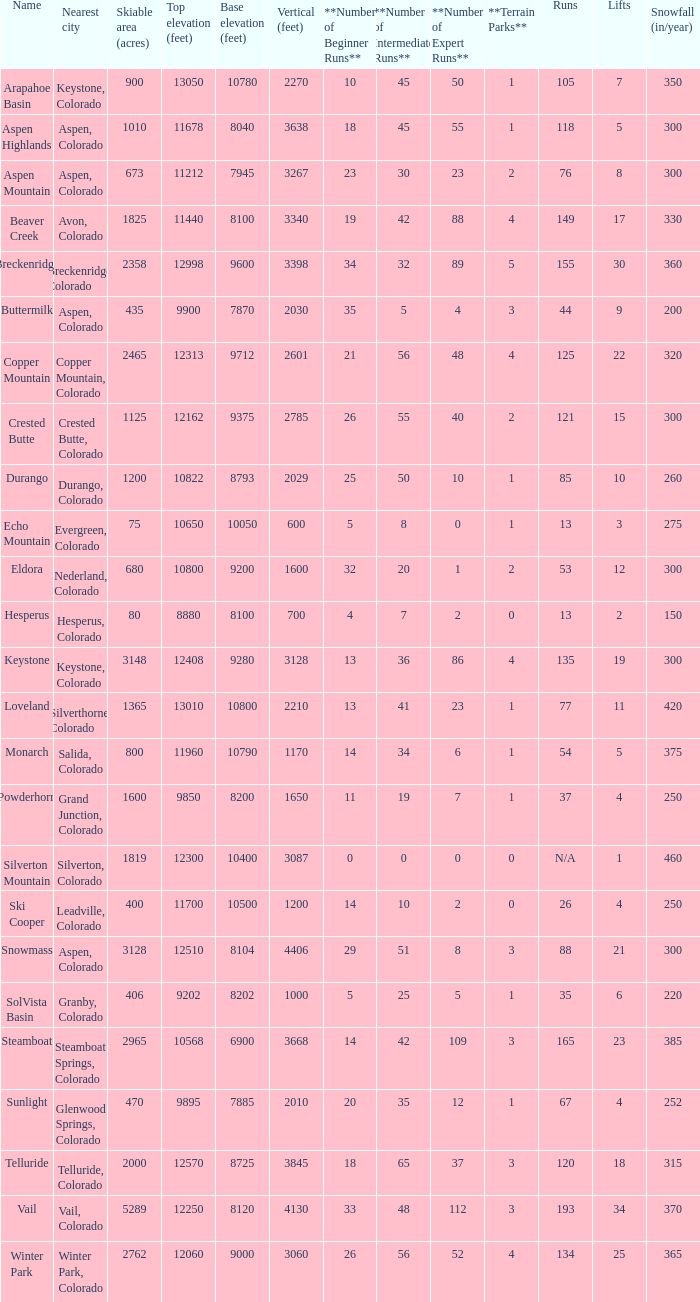Help me parse the entirety of this table. {'header': ['Name', 'Nearest city', 'Skiable area (acres)', 'Top elevation (feet)', 'Base elevation (feet)', 'Vertical (feet)', '**Number of Beginner Runs**', '**Number of Intermediate Runs**', '**Number of Expert Runs**', '**Terrain Parks**', 'Runs', 'Lifts', 'Snowfall (in/year)'], 'rows': [['Arapahoe Basin', 'Keystone, Colorado', '900', '13050', '10780', '2270', '10', '45', '50', '1', '105', '7', '350'], ['Aspen Highlands', 'Aspen, Colorado', '1010', '11678', '8040', '3638', '18', '45', '55', '1', '118', '5', '300'], ['Aspen Mountain', 'Aspen, Colorado', '673', '11212', '7945', '3267', '23', '30', '23', '2', '76', '8', '300'], ['Beaver Creek', 'Avon, Colorado', '1825', '11440', '8100', '3340', '19', '42', '88', '4', '149', '17', '330'], ['Breckenridge', 'Breckenridge, Colorado', '2358', '12998', '9600', '3398', '34', '32', '89', '5', '155', '30', '360'], ['Buttermilk', 'Aspen, Colorado', '435', '9900', '7870', '2030', '35', '5', '4', '3', '44', '9', '200'], ['Copper Mountain', 'Copper Mountain, Colorado', '2465', '12313', '9712', '2601', '21', '56', '48', '4', '125', '22', '320'], ['Crested Butte', 'Crested Butte, Colorado', '1125', '12162', '9375', '2785', '26', '55', '40', '2', '121', '15', '300'], ['Durango', 'Durango, Colorado', '1200', '10822', '8793', '2029', '25', '50', '10', '1', '85', '10', '260'], ['Echo Mountain', 'Evergreen, Colorado', '75', '10650', '10050', '600', '5', '8', '0', '1', '13', '3', '275'], ['Eldora', 'Nederland, Colorado', '680', '10800', '9200', '1600', '32', '20', '1', '2', '53', '12', '300'], ['Hesperus', 'Hesperus, Colorado', '80', '8880', '8100', '700', '4', '7', '2', '0', '13', '2', '150'], ['Keystone', 'Keystone, Colorado', '3148', '12408', '9280', '3128', '13', '36', '86', '4', '135', '19', '300'], ['Loveland', 'Silverthorne, Colorado', '1365', '13010', '10800', '2210', '13', '41', '23', '1', '77', '11', '420'], ['Monarch', 'Salida, Colorado', '800', '11960', '10790', '1170', '14', '34', '6', '1', '54', '5', '375'], ['Powderhorn', 'Grand Junction, Colorado', '1600', '9850', '8200', '1650', '11', '19', '7', '1', '37', '4', '250'], ['Silverton Mountain', 'Silverton, Colorado', '1819', '12300', '10400', '3087', '0', '0', '0', '0', 'N/A', '1', '460'], ['Ski Cooper', 'Leadville, Colorado', '400', '11700', '10500', '1200', '14', '10', '2', '0', '26', '4', '250'], ['Snowmass', 'Aspen, Colorado', '3128', '12510', '8104', '4406', '29', '51', '8', '3', '88', '21', '300'], ['SolVista Basin', 'Granby, Colorado', '406', '9202', '8202', '1000', '5', '25', '5', '1', '35', '6', '220'], ['Steamboat', 'Steamboat Springs, Colorado', '2965', '10568', '6900', '3668', '14', '42', '109', '3', '165', '23', '385'], ['Sunlight', 'Glenwood Springs, Colorado', '470', '9895', '7885', '2010', '20', '35', '12', '1', '67', '4', '252'], ['Telluride', 'Telluride, Colorado', '2000', '12570', '8725', '3845', '18', '65', '37', '3', '120', '18', '315'], ['Vail', 'Vail, Colorado', '5289', '12250', '8120', '4130', '33', '48', '112', '3', '193', '34', '370'], ['Winter Park', 'Winter Park, Colorado', '2762', '12060', '9000', '3060', '26', '56', '52', '4', '134', '25', '365']]} How many resorts have 118 runs? 1.0. 